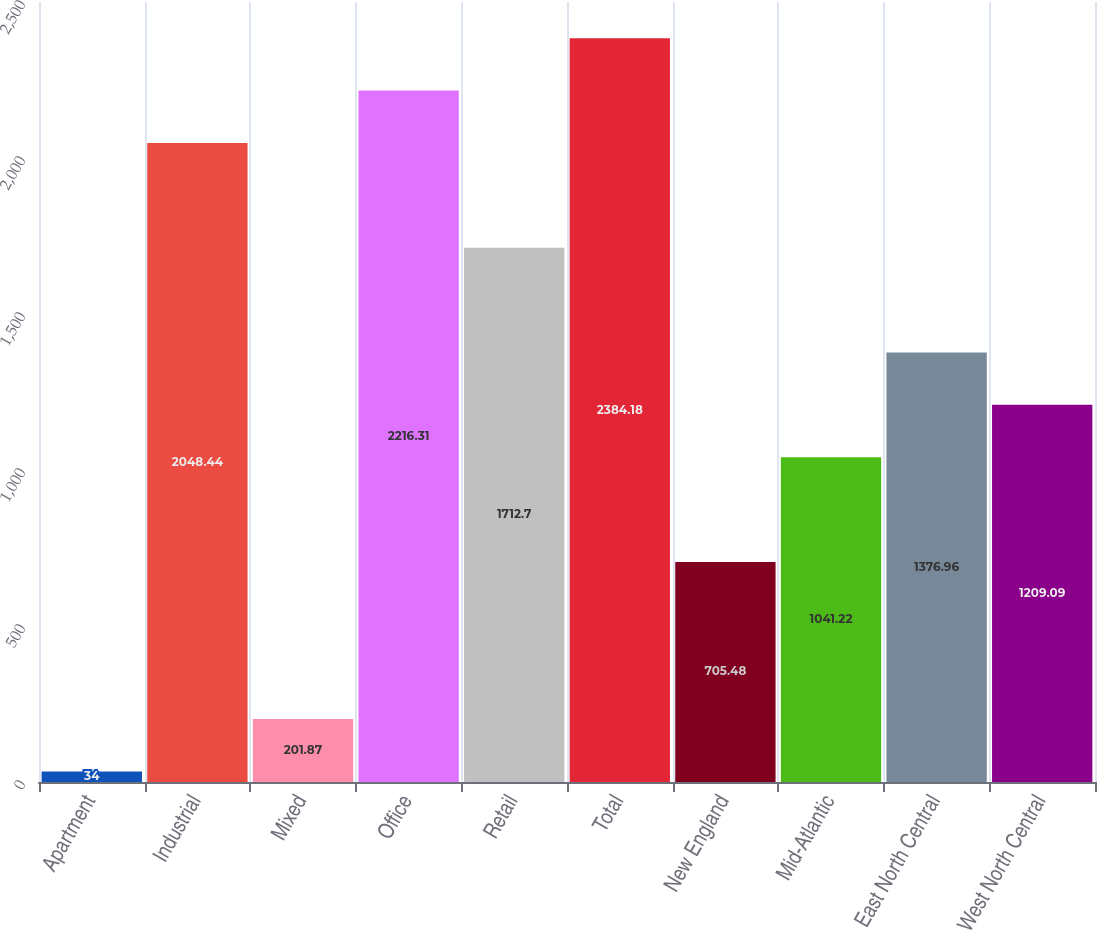Convert chart. <chart><loc_0><loc_0><loc_500><loc_500><bar_chart><fcel>Apartment<fcel>Industrial<fcel>Mixed<fcel>Office<fcel>Retail<fcel>Total<fcel>New England<fcel>Mid-Atlantic<fcel>East North Central<fcel>West North Central<nl><fcel>34<fcel>2048.44<fcel>201.87<fcel>2216.31<fcel>1712.7<fcel>2384.18<fcel>705.48<fcel>1041.22<fcel>1376.96<fcel>1209.09<nl></chart> 